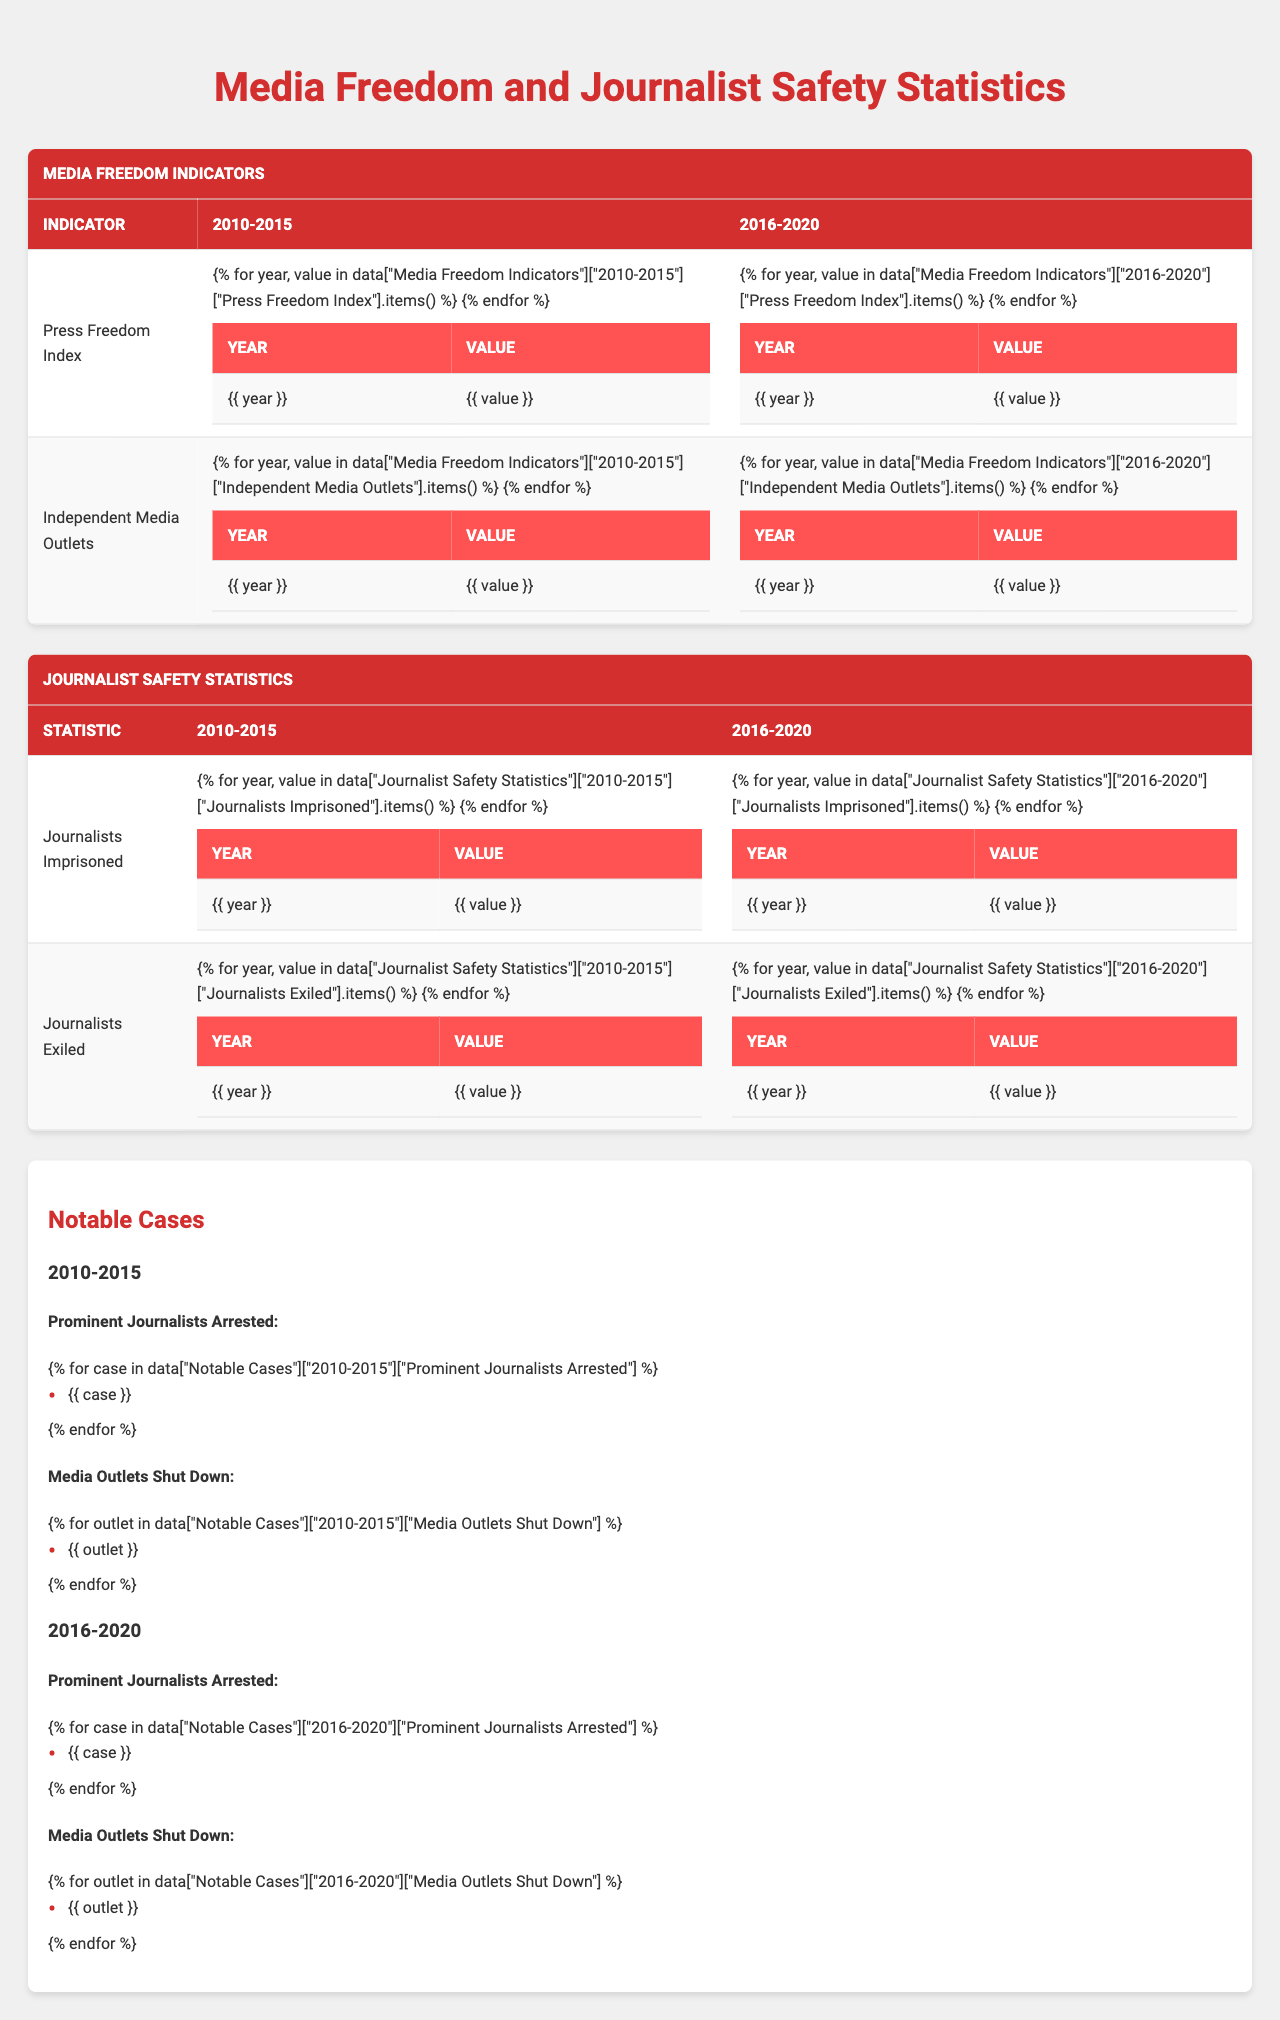What was the Press Freedom Index in 2015? Looking at the "Press Freedom Index" data for the year 2015, the value is found to be 37.6.
Answer: 37.6 How many Independent Media Outlets were there in 2012? From the "Independent Media Outlets" data for the year 2012, the number is 10.
Answer: 10 What was the total number of journalists imprisoned in 2016-2020? Adding the values for journalists imprisoned from 2016 to 2020: 18 (2016) + 22 (2017) + 25 (2018) + 28 (2019) + 32 (2020) = 125.
Answer: 125 Did the number of Independent Media Outlets decline from 2010 to 2015? Checking the data, it shows a decrease from 12 outlets in 2010 to 7 outlets in 2015. Thus, the answer is yes.
Answer: Yes What is the average number of journalists imprisoned from 2010 to 2015? To find the average: sum the values (3 + 5 + 7 + 9 + 12 + 15 = 51) and divide by the number of years (6 years) which equals 51/6 = 8.5.
Answer: 8.5 Which year in 2010-2015 had the highest number of journalists exiled? From the "Journalists Exiled" data, the highest number is 14 in 2015.
Answer: 2015 What was the trend in the Press Freedom Index from 2010 to 2020? The Press Freedom Index shows a consistent decline from 45.2 in 2010 to 32.9 in 2020, indicating a negative trend over the decade.
Answer: Decline How many journalists were exiled in 2018? The data shows that 24 journalists were exiled in 2018.
Answer: 24 Which notable journalist was arrested in 2019? According to the "Notable Cases" section, Fatima Al-Rashid was arrested in 2019.
Answer: Fatima Al-Rashid How many more journalists were imprisoned in 2020 compared to 2015? The difference in the number of imprisoned journalists: 32 (2020) - 15 (2015) equals 17 more journalists imprisoned.
Answer: 17 